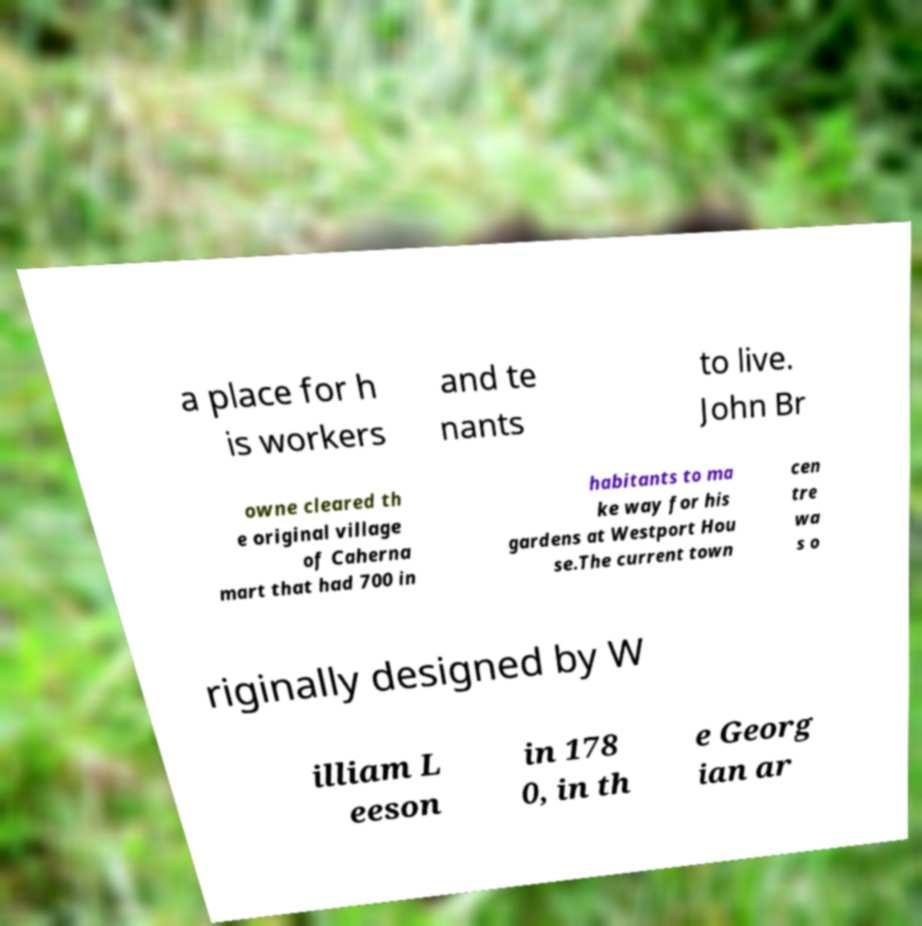For documentation purposes, I need the text within this image transcribed. Could you provide that? a place for h is workers and te nants to live. John Br owne cleared th e original village of Caherna mart that had 700 in habitants to ma ke way for his gardens at Westport Hou se.The current town cen tre wa s o riginally designed by W illiam L eeson in 178 0, in th e Georg ian ar 